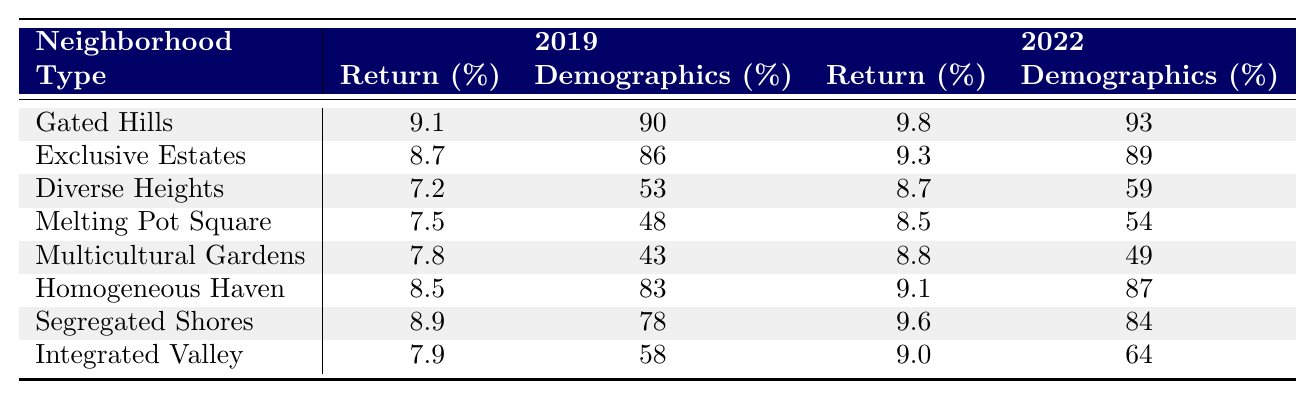What was the return percentage for Gated Hills in 2022? The table displays the return percentage for Gated Hills in 2022, which is stated in the corresponding cell under the 2022 column for returns.
Answer: 9.8 Which neighborhood had the highest return in 2019? In the 2019 returns column, Gated Hills has the highest return at 9.1, as compared to the other neighborhoods listed.
Answer: Gated Hills What is the return difference between Exclusive Estates in 2019 and Segregated Shores in 2022? To find the difference, I take the return for Exclusive Estates in 2019, which is 8.7, and subtract Segregated Shores' return in 2022, which is 9.6. So, 8.7 - 9.6 = -0.9.
Answer: -0.9 What was the demographic percentage for Melting Pot Square in 2019? The demographic percentage for Melting Pot Square in 2019 can be found in the table under that neighborhood's row in the 2019 demographics column. It is specified as 48%.
Answer: 48 Which neighborhood's return percentage increased the most from 2019 to 2022? To determine the neighborhood with the highest increase, I compare the return percentages from 2019 to 2022 for each neighborhood. The increases are: Gated Hills (0.7), Exclusive Estates (0.6), Diverse Heights (1.5), etc. Comparing all, Diverse Heights had the highest increase of 1.5.
Answer: Diverse Heights Is the average demographic percentage for gated neighborhoods higher than that for diverse neighborhoods in 2022? The average demographic percentage for gated neighborhoods (Gated Hills, Exclusive Estates, Homogeneous Haven, Segregated Shores) in 2022 is (93 + 89 + 87 + 84)/4 = 88.25. For diverse neighborhoods (Diverse Heights, Melting Pot Square, Multicultural Gardens, Integrated Valley), it is (59 + 54 + 49 + 64)/4 = 56.5. The average for gated neighborhoods is higher.
Answer: Yes What is the average return percentage of Homogeneous Haven and Integrated Valley in 2022? The return percentage for Homogeneous Haven in 2022 is 9.1 and for Integrated Valley it's 9.0. To find the average, I sum these values: 9.1 + 9.0 = 18.1, then divide by 2: 18.1/2 = 9.05.
Answer: 9.05 Did all neighborhoods see an increase in returns from 2019 to 2022? I compare the return percentages for each neighborhood in 2019 and 2022. Gated Hills, Exclusive Estates, Diverse Heights, etc., all show an increase. However, Melting Pot Square's return is 7.5 in 2019 and only 8.5 in 2022, indicating some neighborhoods did not.
Answer: No 